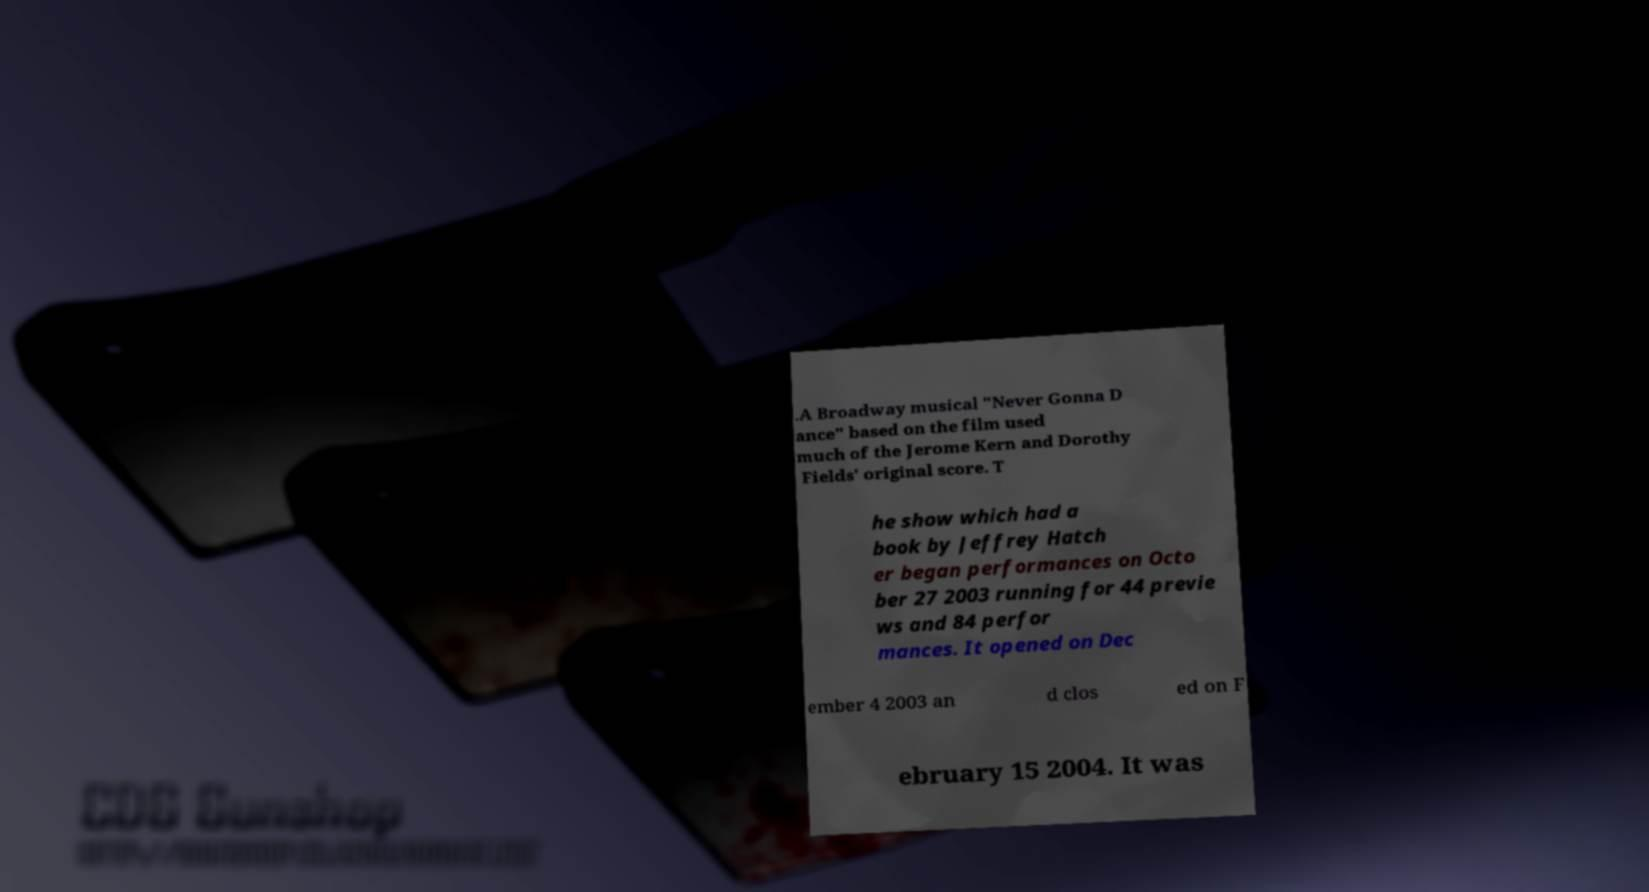Please identify and transcribe the text found in this image. .A Broadway musical "Never Gonna D ance" based on the film used much of the Jerome Kern and Dorothy Fields' original score. T he show which had a book by Jeffrey Hatch er began performances on Octo ber 27 2003 running for 44 previe ws and 84 perfor mances. It opened on Dec ember 4 2003 an d clos ed on F ebruary 15 2004. It was 